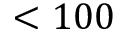<formula> <loc_0><loc_0><loc_500><loc_500>< 1 0 0</formula> 